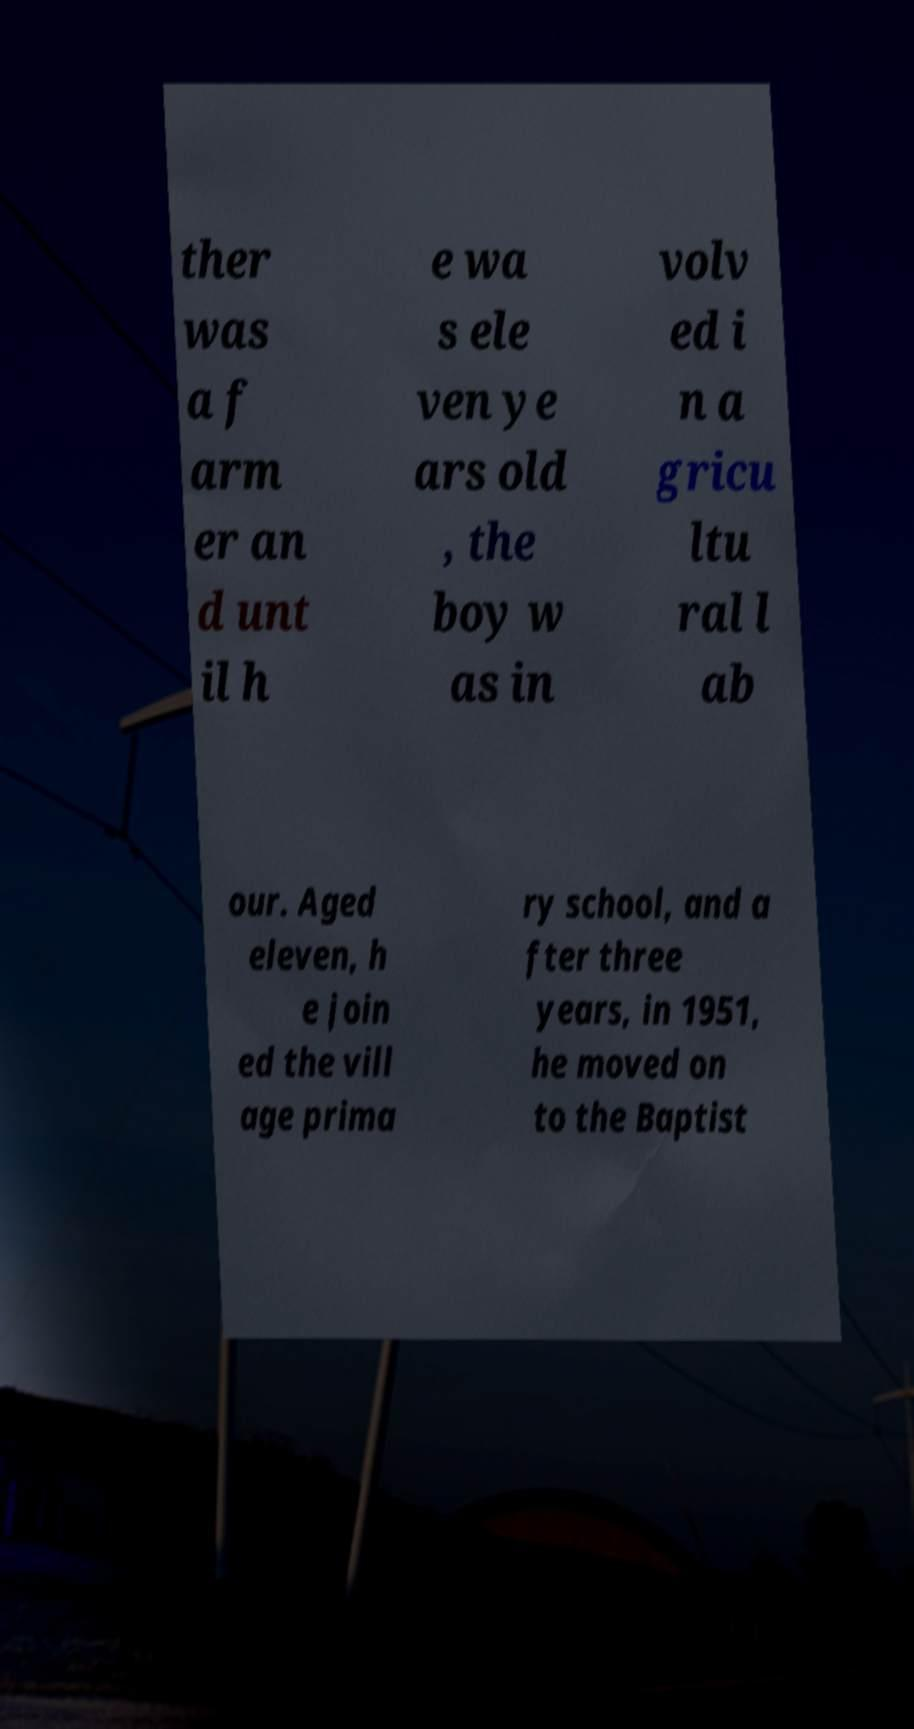There's text embedded in this image that I need extracted. Can you transcribe it verbatim? ther was a f arm er an d unt il h e wa s ele ven ye ars old , the boy w as in volv ed i n a gricu ltu ral l ab our. Aged eleven, h e join ed the vill age prima ry school, and a fter three years, in 1951, he moved on to the Baptist 